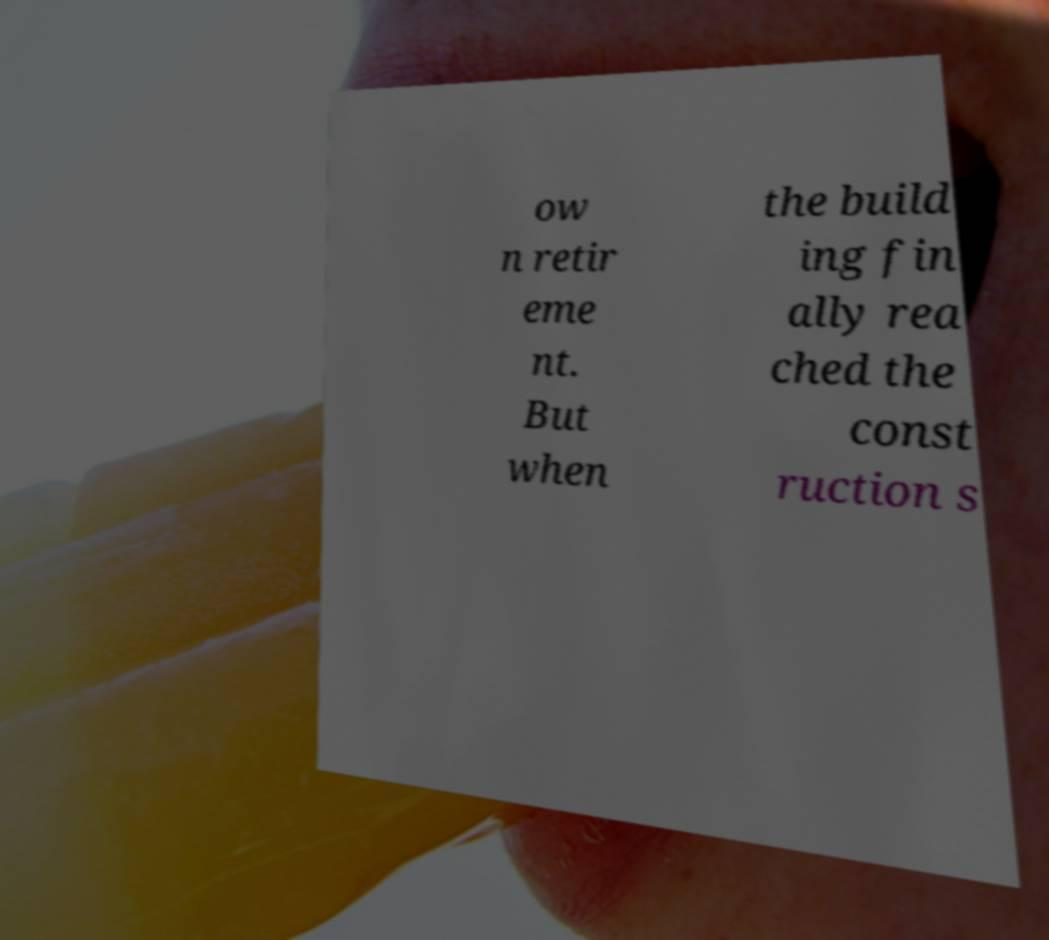Could you assist in decoding the text presented in this image and type it out clearly? ow n retir eme nt. But when the build ing fin ally rea ched the const ruction s 